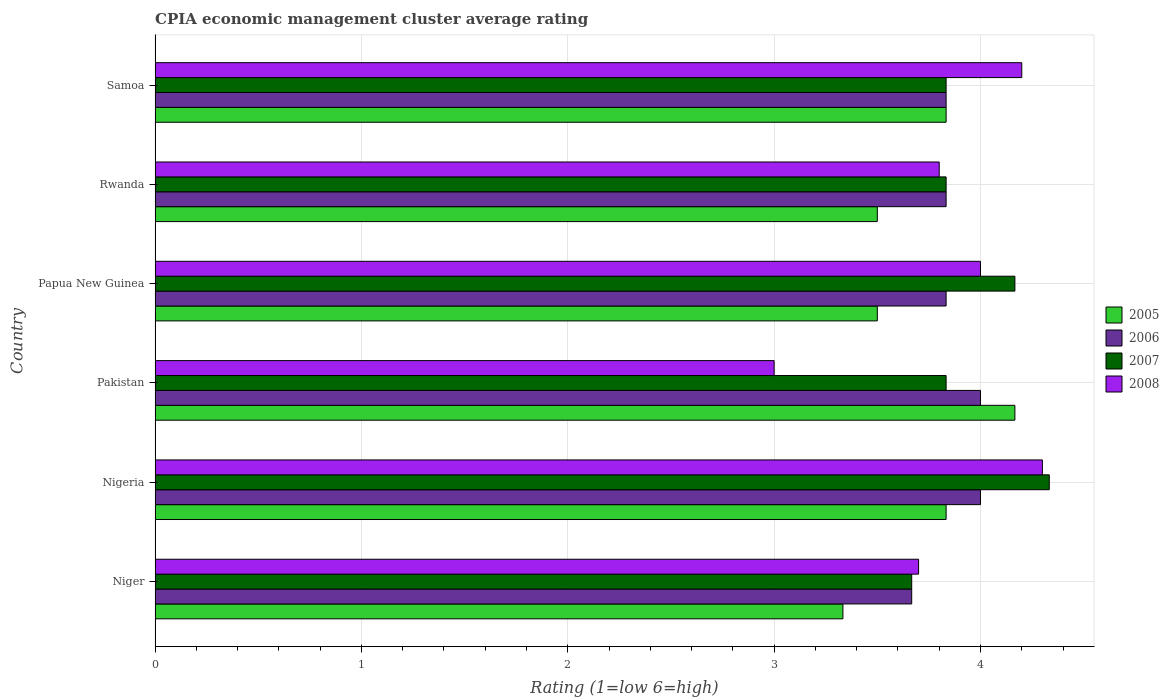How many groups of bars are there?
Keep it short and to the point. 6. Are the number of bars per tick equal to the number of legend labels?
Provide a short and direct response. Yes. How many bars are there on the 6th tick from the top?
Give a very brief answer. 4. What is the label of the 3rd group of bars from the top?
Your response must be concise. Papua New Guinea. In how many cases, is the number of bars for a given country not equal to the number of legend labels?
Your response must be concise. 0. What is the CPIA rating in 2006 in Nigeria?
Ensure brevity in your answer.  4. Across all countries, what is the maximum CPIA rating in 2007?
Offer a very short reply. 4.33. Across all countries, what is the minimum CPIA rating in 2006?
Ensure brevity in your answer.  3.67. In which country was the CPIA rating in 2007 maximum?
Your answer should be very brief. Nigeria. In which country was the CPIA rating in 2006 minimum?
Ensure brevity in your answer.  Niger. What is the total CPIA rating in 2005 in the graph?
Provide a succinct answer. 22.17. What is the difference between the CPIA rating in 2008 in Nigeria and that in Papua New Guinea?
Give a very brief answer. 0.3. What is the difference between the CPIA rating in 2008 in Papua New Guinea and the CPIA rating in 2006 in Rwanda?
Make the answer very short. 0.17. What is the average CPIA rating in 2008 per country?
Make the answer very short. 3.83. What is the difference between the CPIA rating in 2007 and CPIA rating in 2008 in Pakistan?
Offer a very short reply. 0.83. In how many countries, is the CPIA rating in 2006 greater than 2.6 ?
Provide a short and direct response. 6. What is the ratio of the CPIA rating in 2005 in Papua New Guinea to that in Samoa?
Make the answer very short. 0.91. What is the difference between the highest and the second highest CPIA rating in 2007?
Provide a short and direct response. 0.17. What is the difference between the highest and the lowest CPIA rating in 2007?
Your response must be concise. 0.67. Is the sum of the CPIA rating in 2008 in Niger and Rwanda greater than the maximum CPIA rating in 2007 across all countries?
Ensure brevity in your answer.  Yes. Is it the case that in every country, the sum of the CPIA rating in 2007 and CPIA rating in 2005 is greater than the sum of CPIA rating in 2006 and CPIA rating in 2008?
Keep it short and to the point. Yes. What does the 4th bar from the top in Samoa represents?
Provide a short and direct response. 2005. What does the 1st bar from the bottom in Nigeria represents?
Your answer should be compact. 2005. Is it the case that in every country, the sum of the CPIA rating in 2005 and CPIA rating in 2007 is greater than the CPIA rating in 2008?
Your answer should be very brief. Yes. What is the difference between two consecutive major ticks on the X-axis?
Make the answer very short. 1. Are the values on the major ticks of X-axis written in scientific E-notation?
Make the answer very short. No. Does the graph contain grids?
Provide a succinct answer. Yes. Where does the legend appear in the graph?
Ensure brevity in your answer.  Center right. How many legend labels are there?
Your response must be concise. 4. How are the legend labels stacked?
Provide a succinct answer. Vertical. What is the title of the graph?
Your answer should be very brief. CPIA economic management cluster average rating. What is the label or title of the X-axis?
Keep it short and to the point. Rating (1=low 6=high). What is the Rating (1=low 6=high) of 2005 in Niger?
Give a very brief answer. 3.33. What is the Rating (1=low 6=high) of 2006 in Niger?
Ensure brevity in your answer.  3.67. What is the Rating (1=low 6=high) in 2007 in Niger?
Keep it short and to the point. 3.67. What is the Rating (1=low 6=high) of 2008 in Niger?
Ensure brevity in your answer.  3.7. What is the Rating (1=low 6=high) of 2005 in Nigeria?
Provide a succinct answer. 3.83. What is the Rating (1=low 6=high) of 2006 in Nigeria?
Offer a very short reply. 4. What is the Rating (1=low 6=high) of 2007 in Nigeria?
Your answer should be compact. 4.33. What is the Rating (1=low 6=high) in 2005 in Pakistan?
Make the answer very short. 4.17. What is the Rating (1=low 6=high) of 2007 in Pakistan?
Give a very brief answer. 3.83. What is the Rating (1=low 6=high) of 2005 in Papua New Guinea?
Make the answer very short. 3.5. What is the Rating (1=low 6=high) in 2006 in Papua New Guinea?
Offer a terse response. 3.83. What is the Rating (1=low 6=high) in 2007 in Papua New Guinea?
Give a very brief answer. 4.17. What is the Rating (1=low 6=high) of 2008 in Papua New Guinea?
Provide a succinct answer. 4. What is the Rating (1=low 6=high) in 2006 in Rwanda?
Provide a succinct answer. 3.83. What is the Rating (1=low 6=high) in 2007 in Rwanda?
Give a very brief answer. 3.83. What is the Rating (1=low 6=high) in 2005 in Samoa?
Offer a terse response. 3.83. What is the Rating (1=low 6=high) in 2006 in Samoa?
Offer a terse response. 3.83. What is the Rating (1=low 6=high) of 2007 in Samoa?
Offer a very short reply. 3.83. What is the Rating (1=low 6=high) in 2008 in Samoa?
Keep it short and to the point. 4.2. Across all countries, what is the maximum Rating (1=low 6=high) of 2005?
Your response must be concise. 4.17. Across all countries, what is the maximum Rating (1=low 6=high) of 2007?
Offer a terse response. 4.33. Across all countries, what is the maximum Rating (1=low 6=high) of 2008?
Keep it short and to the point. 4.3. Across all countries, what is the minimum Rating (1=low 6=high) in 2005?
Your answer should be compact. 3.33. Across all countries, what is the minimum Rating (1=low 6=high) of 2006?
Your response must be concise. 3.67. Across all countries, what is the minimum Rating (1=low 6=high) of 2007?
Your response must be concise. 3.67. Across all countries, what is the minimum Rating (1=low 6=high) in 2008?
Offer a very short reply. 3. What is the total Rating (1=low 6=high) in 2005 in the graph?
Give a very brief answer. 22.17. What is the total Rating (1=low 6=high) of 2006 in the graph?
Offer a very short reply. 23.17. What is the total Rating (1=low 6=high) in 2007 in the graph?
Your answer should be very brief. 23.67. What is the total Rating (1=low 6=high) in 2008 in the graph?
Make the answer very short. 23. What is the difference between the Rating (1=low 6=high) in 2006 in Niger and that in Nigeria?
Your answer should be very brief. -0.33. What is the difference between the Rating (1=low 6=high) of 2007 in Niger and that in Nigeria?
Offer a very short reply. -0.67. What is the difference between the Rating (1=low 6=high) of 2008 in Niger and that in Nigeria?
Give a very brief answer. -0.6. What is the difference between the Rating (1=low 6=high) of 2006 in Niger and that in Pakistan?
Keep it short and to the point. -0.33. What is the difference between the Rating (1=low 6=high) of 2008 in Niger and that in Pakistan?
Your answer should be compact. 0.7. What is the difference between the Rating (1=low 6=high) in 2005 in Niger and that in Papua New Guinea?
Offer a terse response. -0.17. What is the difference between the Rating (1=low 6=high) in 2007 in Niger and that in Papua New Guinea?
Offer a very short reply. -0.5. What is the difference between the Rating (1=low 6=high) of 2005 in Niger and that in Rwanda?
Offer a terse response. -0.17. What is the difference between the Rating (1=low 6=high) of 2008 in Niger and that in Rwanda?
Ensure brevity in your answer.  -0.1. What is the difference between the Rating (1=low 6=high) of 2005 in Niger and that in Samoa?
Provide a short and direct response. -0.5. What is the difference between the Rating (1=low 6=high) of 2007 in Niger and that in Samoa?
Offer a very short reply. -0.17. What is the difference between the Rating (1=low 6=high) in 2007 in Nigeria and that in Pakistan?
Offer a very short reply. 0.5. What is the difference between the Rating (1=low 6=high) of 2008 in Nigeria and that in Pakistan?
Keep it short and to the point. 1.3. What is the difference between the Rating (1=low 6=high) of 2005 in Nigeria and that in Papua New Guinea?
Your answer should be very brief. 0.33. What is the difference between the Rating (1=low 6=high) in 2008 in Nigeria and that in Papua New Guinea?
Ensure brevity in your answer.  0.3. What is the difference between the Rating (1=low 6=high) of 2005 in Nigeria and that in Rwanda?
Your response must be concise. 0.33. What is the difference between the Rating (1=low 6=high) of 2006 in Nigeria and that in Rwanda?
Provide a short and direct response. 0.17. What is the difference between the Rating (1=low 6=high) in 2008 in Nigeria and that in Rwanda?
Ensure brevity in your answer.  0.5. What is the difference between the Rating (1=low 6=high) of 2005 in Nigeria and that in Samoa?
Offer a very short reply. 0. What is the difference between the Rating (1=low 6=high) in 2006 in Nigeria and that in Samoa?
Offer a terse response. 0.17. What is the difference between the Rating (1=low 6=high) of 2007 in Nigeria and that in Samoa?
Your answer should be very brief. 0.5. What is the difference between the Rating (1=low 6=high) of 2007 in Pakistan and that in Papua New Guinea?
Your answer should be compact. -0.33. What is the difference between the Rating (1=low 6=high) of 2008 in Pakistan and that in Papua New Guinea?
Provide a succinct answer. -1. What is the difference between the Rating (1=low 6=high) in 2008 in Pakistan and that in Rwanda?
Ensure brevity in your answer.  -0.8. What is the difference between the Rating (1=low 6=high) of 2005 in Pakistan and that in Samoa?
Give a very brief answer. 0.33. What is the difference between the Rating (1=low 6=high) in 2006 in Pakistan and that in Samoa?
Offer a terse response. 0.17. What is the difference between the Rating (1=low 6=high) in 2007 in Pakistan and that in Samoa?
Ensure brevity in your answer.  0. What is the difference between the Rating (1=low 6=high) in 2008 in Pakistan and that in Samoa?
Give a very brief answer. -1.2. What is the difference between the Rating (1=low 6=high) of 2005 in Papua New Guinea and that in Rwanda?
Give a very brief answer. 0. What is the difference between the Rating (1=low 6=high) in 2006 in Papua New Guinea and that in Rwanda?
Ensure brevity in your answer.  0. What is the difference between the Rating (1=low 6=high) in 2007 in Papua New Guinea and that in Rwanda?
Make the answer very short. 0.33. What is the difference between the Rating (1=low 6=high) in 2008 in Papua New Guinea and that in Rwanda?
Offer a very short reply. 0.2. What is the difference between the Rating (1=low 6=high) in 2005 in Papua New Guinea and that in Samoa?
Offer a very short reply. -0.33. What is the difference between the Rating (1=low 6=high) in 2006 in Papua New Guinea and that in Samoa?
Your response must be concise. 0. What is the difference between the Rating (1=low 6=high) of 2007 in Papua New Guinea and that in Samoa?
Offer a terse response. 0.33. What is the difference between the Rating (1=low 6=high) of 2006 in Rwanda and that in Samoa?
Give a very brief answer. 0. What is the difference between the Rating (1=low 6=high) in 2005 in Niger and the Rating (1=low 6=high) in 2006 in Nigeria?
Keep it short and to the point. -0.67. What is the difference between the Rating (1=low 6=high) in 2005 in Niger and the Rating (1=low 6=high) in 2007 in Nigeria?
Offer a very short reply. -1. What is the difference between the Rating (1=low 6=high) in 2005 in Niger and the Rating (1=low 6=high) in 2008 in Nigeria?
Your answer should be very brief. -0.97. What is the difference between the Rating (1=low 6=high) of 2006 in Niger and the Rating (1=low 6=high) of 2008 in Nigeria?
Offer a terse response. -0.63. What is the difference between the Rating (1=low 6=high) in 2007 in Niger and the Rating (1=low 6=high) in 2008 in Nigeria?
Give a very brief answer. -0.63. What is the difference between the Rating (1=low 6=high) of 2005 in Niger and the Rating (1=low 6=high) of 2006 in Pakistan?
Offer a terse response. -0.67. What is the difference between the Rating (1=low 6=high) of 2005 in Niger and the Rating (1=low 6=high) of 2007 in Pakistan?
Offer a terse response. -0.5. What is the difference between the Rating (1=low 6=high) of 2006 in Niger and the Rating (1=low 6=high) of 2007 in Pakistan?
Make the answer very short. -0.17. What is the difference between the Rating (1=low 6=high) in 2005 in Niger and the Rating (1=low 6=high) in 2006 in Papua New Guinea?
Provide a short and direct response. -0.5. What is the difference between the Rating (1=low 6=high) in 2005 in Niger and the Rating (1=low 6=high) in 2008 in Papua New Guinea?
Your answer should be compact. -0.67. What is the difference between the Rating (1=low 6=high) of 2007 in Niger and the Rating (1=low 6=high) of 2008 in Papua New Guinea?
Provide a succinct answer. -0.33. What is the difference between the Rating (1=low 6=high) of 2005 in Niger and the Rating (1=low 6=high) of 2006 in Rwanda?
Your answer should be compact. -0.5. What is the difference between the Rating (1=low 6=high) in 2005 in Niger and the Rating (1=low 6=high) in 2008 in Rwanda?
Your answer should be very brief. -0.47. What is the difference between the Rating (1=low 6=high) in 2006 in Niger and the Rating (1=low 6=high) in 2008 in Rwanda?
Ensure brevity in your answer.  -0.13. What is the difference between the Rating (1=low 6=high) in 2007 in Niger and the Rating (1=low 6=high) in 2008 in Rwanda?
Your answer should be compact. -0.13. What is the difference between the Rating (1=low 6=high) in 2005 in Niger and the Rating (1=low 6=high) in 2007 in Samoa?
Provide a short and direct response. -0.5. What is the difference between the Rating (1=low 6=high) in 2005 in Niger and the Rating (1=low 6=high) in 2008 in Samoa?
Provide a succinct answer. -0.87. What is the difference between the Rating (1=low 6=high) in 2006 in Niger and the Rating (1=low 6=high) in 2008 in Samoa?
Offer a terse response. -0.53. What is the difference between the Rating (1=low 6=high) in 2007 in Niger and the Rating (1=low 6=high) in 2008 in Samoa?
Provide a short and direct response. -0.53. What is the difference between the Rating (1=low 6=high) in 2005 in Nigeria and the Rating (1=low 6=high) in 2006 in Pakistan?
Your response must be concise. -0.17. What is the difference between the Rating (1=low 6=high) of 2005 in Nigeria and the Rating (1=low 6=high) of 2007 in Pakistan?
Provide a short and direct response. 0. What is the difference between the Rating (1=low 6=high) in 2006 in Nigeria and the Rating (1=low 6=high) in 2007 in Pakistan?
Provide a short and direct response. 0.17. What is the difference between the Rating (1=low 6=high) in 2007 in Nigeria and the Rating (1=low 6=high) in 2008 in Pakistan?
Offer a very short reply. 1.33. What is the difference between the Rating (1=low 6=high) of 2005 in Nigeria and the Rating (1=low 6=high) of 2006 in Papua New Guinea?
Ensure brevity in your answer.  0. What is the difference between the Rating (1=low 6=high) of 2005 in Nigeria and the Rating (1=low 6=high) of 2007 in Papua New Guinea?
Give a very brief answer. -0.33. What is the difference between the Rating (1=low 6=high) of 2005 in Nigeria and the Rating (1=low 6=high) of 2008 in Papua New Guinea?
Keep it short and to the point. -0.17. What is the difference between the Rating (1=low 6=high) of 2007 in Nigeria and the Rating (1=low 6=high) of 2008 in Papua New Guinea?
Your response must be concise. 0.33. What is the difference between the Rating (1=low 6=high) of 2005 in Nigeria and the Rating (1=low 6=high) of 2008 in Rwanda?
Your response must be concise. 0.03. What is the difference between the Rating (1=low 6=high) of 2006 in Nigeria and the Rating (1=low 6=high) of 2007 in Rwanda?
Offer a terse response. 0.17. What is the difference between the Rating (1=low 6=high) in 2006 in Nigeria and the Rating (1=low 6=high) in 2008 in Rwanda?
Give a very brief answer. 0.2. What is the difference between the Rating (1=low 6=high) of 2007 in Nigeria and the Rating (1=low 6=high) of 2008 in Rwanda?
Keep it short and to the point. 0.53. What is the difference between the Rating (1=low 6=high) of 2005 in Nigeria and the Rating (1=low 6=high) of 2008 in Samoa?
Your answer should be compact. -0.37. What is the difference between the Rating (1=low 6=high) in 2007 in Nigeria and the Rating (1=low 6=high) in 2008 in Samoa?
Offer a very short reply. 0.13. What is the difference between the Rating (1=low 6=high) of 2005 in Pakistan and the Rating (1=low 6=high) of 2006 in Papua New Guinea?
Your answer should be compact. 0.33. What is the difference between the Rating (1=low 6=high) of 2007 in Pakistan and the Rating (1=low 6=high) of 2008 in Papua New Guinea?
Ensure brevity in your answer.  -0.17. What is the difference between the Rating (1=low 6=high) of 2005 in Pakistan and the Rating (1=low 6=high) of 2008 in Rwanda?
Keep it short and to the point. 0.37. What is the difference between the Rating (1=low 6=high) in 2006 in Pakistan and the Rating (1=low 6=high) in 2008 in Rwanda?
Offer a very short reply. 0.2. What is the difference between the Rating (1=low 6=high) of 2005 in Pakistan and the Rating (1=low 6=high) of 2006 in Samoa?
Make the answer very short. 0.33. What is the difference between the Rating (1=low 6=high) in 2005 in Pakistan and the Rating (1=low 6=high) in 2008 in Samoa?
Offer a terse response. -0.03. What is the difference between the Rating (1=low 6=high) in 2006 in Pakistan and the Rating (1=low 6=high) in 2007 in Samoa?
Ensure brevity in your answer.  0.17. What is the difference between the Rating (1=low 6=high) of 2007 in Pakistan and the Rating (1=low 6=high) of 2008 in Samoa?
Your answer should be compact. -0.37. What is the difference between the Rating (1=low 6=high) of 2006 in Papua New Guinea and the Rating (1=low 6=high) of 2008 in Rwanda?
Keep it short and to the point. 0.03. What is the difference between the Rating (1=low 6=high) in 2007 in Papua New Guinea and the Rating (1=low 6=high) in 2008 in Rwanda?
Your answer should be very brief. 0.37. What is the difference between the Rating (1=low 6=high) in 2006 in Papua New Guinea and the Rating (1=low 6=high) in 2007 in Samoa?
Provide a succinct answer. 0. What is the difference between the Rating (1=low 6=high) in 2006 in Papua New Guinea and the Rating (1=low 6=high) in 2008 in Samoa?
Keep it short and to the point. -0.37. What is the difference between the Rating (1=low 6=high) in 2007 in Papua New Guinea and the Rating (1=low 6=high) in 2008 in Samoa?
Provide a short and direct response. -0.03. What is the difference between the Rating (1=low 6=high) of 2005 in Rwanda and the Rating (1=low 6=high) of 2006 in Samoa?
Provide a short and direct response. -0.33. What is the difference between the Rating (1=low 6=high) in 2006 in Rwanda and the Rating (1=low 6=high) in 2008 in Samoa?
Offer a very short reply. -0.37. What is the difference between the Rating (1=low 6=high) in 2007 in Rwanda and the Rating (1=low 6=high) in 2008 in Samoa?
Your answer should be compact. -0.37. What is the average Rating (1=low 6=high) of 2005 per country?
Your answer should be very brief. 3.69. What is the average Rating (1=low 6=high) of 2006 per country?
Provide a succinct answer. 3.86. What is the average Rating (1=low 6=high) of 2007 per country?
Provide a short and direct response. 3.94. What is the average Rating (1=low 6=high) of 2008 per country?
Offer a terse response. 3.83. What is the difference between the Rating (1=low 6=high) of 2005 and Rating (1=low 6=high) of 2006 in Niger?
Provide a succinct answer. -0.33. What is the difference between the Rating (1=low 6=high) in 2005 and Rating (1=low 6=high) in 2007 in Niger?
Your answer should be very brief. -0.33. What is the difference between the Rating (1=low 6=high) of 2005 and Rating (1=low 6=high) of 2008 in Niger?
Offer a terse response. -0.37. What is the difference between the Rating (1=low 6=high) in 2006 and Rating (1=low 6=high) in 2007 in Niger?
Make the answer very short. 0. What is the difference between the Rating (1=low 6=high) in 2006 and Rating (1=low 6=high) in 2008 in Niger?
Your response must be concise. -0.03. What is the difference between the Rating (1=low 6=high) in 2007 and Rating (1=low 6=high) in 2008 in Niger?
Offer a very short reply. -0.03. What is the difference between the Rating (1=low 6=high) of 2005 and Rating (1=low 6=high) of 2006 in Nigeria?
Provide a succinct answer. -0.17. What is the difference between the Rating (1=low 6=high) in 2005 and Rating (1=low 6=high) in 2007 in Nigeria?
Give a very brief answer. -0.5. What is the difference between the Rating (1=low 6=high) of 2005 and Rating (1=low 6=high) of 2008 in Nigeria?
Provide a short and direct response. -0.47. What is the difference between the Rating (1=low 6=high) of 2006 and Rating (1=low 6=high) of 2008 in Nigeria?
Your answer should be very brief. -0.3. What is the difference between the Rating (1=low 6=high) in 2005 and Rating (1=low 6=high) in 2007 in Pakistan?
Ensure brevity in your answer.  0.33. What is the difference between the Rating (1=low 6=high) of 2005 and Rating (1=low 6=high) of 2008 in Pakistan?
Provide a succinct answer. 1.17. What is the difference between the Rating (1=low 6=high) of 2005 and Rating (1=low 6=high) of 2007 in Papua New Guinea?
Ensure brevity in your answer.  -0.67. What is the difference between the Rating (1=low 6=high) in 2006 and Rating (1=low 6=high) in 2007 in Papua New Guinea?
Ensure brevity in your answer.  -0.33. What is the difference between the Rating (1=low 6=high) of 2006 and Rating (1=low 6=high) of 2008 in Papua New Guinea?
Provide a succinct answer. -0.17. What is the difference between the Rating (1=low 6=high) of 2007 and Rating (1=low 6=high) of 2008 in Papua New Guinea?
Provide a short and direct response. 0.17. What is the difference between the Rating (1=low 6=high) in 2005 and Rating (1=low 6=high) in 2007 in Rwanda?
Offer a terse response. -0.33. What is the difference between the Rating (1=low 6=high) in 2005 and Rating (1=low 6=high) in 2008 in Rwanda?
Your answer should be very brief. -0.3. What is the difference between the Rating (1=low 6=high) of 2006 and Rating (1=low 6=high) of 2007 in Rwanda?
Your response must be concise. 0. What is the difference between the Rating (1=low 6=high) in 2007 and Rating (1=low 6=high) in 2008 in Rwanda?
Offer a terse response. 0.03. What is the difference between the Rating (1=low 6=high) in 2005 and Rating (1=low 6=high) in 2007 in Samoa?
Keep it short and to the point. 0. What is the difference between the Rating (1=low 6=high) in 2005 and Rating (1=low 6=high) in 2008 in Samoa?
Offer a terse response. -0.37. What is the difference between the Rating (1=low 6=high) in 2006 and Rating (1=low 6=high) in 2008 in Samoa?
Your answer should be compact. -0.37. What is the difference between the Rating (1=low 6=high) of 2007 and Rating (1=low 6=high) of 2008 in Samoa?
Your answer should be very brief. -0.37. What is the ratio of the Rating (1=low 6=high) of 2005 in Niger to that in Nigeria?
Make the answer very short. 0.87. What is the ratio of the Rating (1=low 6=high) of 2007 in Niger to that in Nigeria?
Keep it short and to the point. 0.85. What is the ratio of the Rating (1=low 6=high) of 2008 in Niger to that in Nigeria?
Keep it short and to the point. 0.86. What is the ratio of the Rating (1=low 6=high) of 2005 in Niger to that in Pakistan?
Offer a terse response. 0.8. What is the ratio of the Rating (1=low 6=high) of 2007 in Niger to that in Pakistan?
Your response must be concise. 0.96. What is the ratio of the Rating (1=low 6=high) of 2008 in Niger to that in Pakistan?
Make the answer very short. 1.23. What is the ratio of the Rating (1=low 6=high) of 2005 in Niger to that in Papua New Guinea?
Make the answer very short. 0.95. What is the ratio of the Rating (1=low 6=high) in 2006 in Niger to that in Papua New Guinea?
Keep it short and to the point. 0.96. What is the ratio of the Rating (1=low 6=high) of 2008 in Niger to that in Papua New Guinea?
Your answer should be very brief. 0.93. What is the ratio of the Rating (1=low 6=high) in 2006 in Niger to that in Rwanda?
Keep it short and to the point. 0.96. What is the ratio of the Rating (1=low 6=high) in 2007 in Niger to that in Rwanda?
Provide a short and direct response. 0.96. What is the ratio of the Rating (1=low 6=high) of 2008 in Niger to that in Rwanda?
Give a very brief answer. 0.97. What is the ratio of the Rating (1=low 6=high) of 2005 in Niger to that in Samoa?
Your answer should be very brief. 0.87. What is the ratio of the Rating (1=low 6=high) in 2006 in Niger to that in Samoa?
Ensure brevity in your answer.  0.96. What is the ratio of the Rating (1=low 6=high) in 2007 in Niger to that in Samoa?
Your answer should be very brief. 0.96. What is the ratio of the Rating (1=low 6=high) of 2008 in Niger to that in Samoa?
Provide a short and direct response. 0.88. What is the ratio of the Rating (1=low 6=high) of 2006 in Nigeria to that in Pakistan?
Your answer should be compact. 1. What is the ratio of the Rating (1=low 6=high) of 2007 in Nigeria to that in Pakistan?
Keep it short and to the point. 1.13. What is the ratio of the Rating (1=low 6=high) of 2008 in Nigeria to that in Pakistan?
Your answer should be very brief. 1.43. What is the ratio of the Rating (1=low 6=high) in 2005 in Nigeria to that in Papua New Guinea?
Give a very brief answer. 1.1. What is the ratio of the Rating (1=low 6=high) of 2006 in Nigeria to that in Papua New Guinea?
Your answer should be very brief. 1.04. What is the ratio of the Rating (1=low 6=high) in 2008 in Nigeria to that in Papua New Guinea?
Keep it short and to the point. 1.07. What is the ratio of the Rating (1=low 6=high) of 2005 in Nigeria to that in Rwanda?
Ensure brevity in your answer.  1.1. What is the ratio of the Rating (1=low 6=high) in 2006 in Nigeria to that in Rwanda?
Ensure brevity in your answer.  1.04. What is the ratio of the Rating (1=low 6=high) of 2007 in Nigeria to that in Rwanda?
Provide a succinct answer. 1.13. What is the ratio of the Rating (1=low 6=high) of 2008 in Nigeria to that in Rwanda?
Provide a succinct answer. 1.13. What is the ratio of the Rating (1=low 6=high) of 2005 in Nigeria to that in Samoa?
Provide a short and direct response. 1. What is the ratio of the Rating (1=low 6=high) of 2006 in Nigeria to that in Samoa?
Give a very brief answer. 1.04. What is the ratio of the Rating (1=low 6=high) in 2007 in Nigeria to that in Samoa?
Give a very brief answer. 1.13. What is the ratio of the Rating (1=low 6=high) in 2008 in Nigeria to that in Samoa?
Your response must be concise. 1.02. What is the ratio of the Rating (1=low 6=high) of 2005 in Pakistan to that in Papua New Guinea?
Keep it short and to the point. 1.19. What is the ratio of the Rating (1=low 6=high) in 2006 in Pakistan to that in Papua New Guinea?
Your response must be concise. 1.04. What is the ratio of the Rating (1=low 6=high) in 2007 in Pakistan to that in Papua New Guinea?
Your answer should be very brief. 0.92. What is the ratio of the Rating (1=low 6=high) in 2008 in Pakistan to that in Papua New Guinea?
Offer a terse response. 0.75. What is the ratio of the Rating (1=low 6=high) of 2005 in Pakistan to that in Rwanda?
Give a very brief answer. 1.19. What is the ratio of the Rating (1=low 6=high) of 2006 in Pakistan to that in Rwanda?
Keep it short and to the point. 1.04. What is the ratio of the Rating (1=low 6=high) in 2008 in Pakistan to that in Rwanda?
Offer a terse response. 0.79. What is the ratio of the Rating (1=low 6=high) in 2005 in Pakistan to that in Samoa?
Offer a terse response. 1.09. What is the ratio of the Rating (1=low 6=high) of 2006 in Pakistan to that in Samoa?
Ensure brevity in your answer.  1.04. What is the ratio of the Rating (1=low 6=high) in 2005 in Papua New Guinea to that in Rwanda?
Offer a terse response. 1. What is the ratio of the Rating (1=low 6=high) in 2006 in Papua New Guinea to that in Rwanda?
Ensure brevity in your answer.  1. What is the ratio of the Rating (1=low 6=high) of 2007 in Papua New Guinea to that in Rwanda?
Offer a very short reply. 1.09. What is the ratio of the Rating (1=low 6=high) in 2008 in Papua New Guinea to that in Rwanda?
Your response must be concise. 1.05. What is the ratio of the Rating (1=low 6=high) of 2005 in Papua New Guinea to that in Samoa?
Your response must be concise. 0.91. What is the ratio of the Rating (1=low 6=high) in 2007 in Papua New Guinea to that in Samoa?
Your answer should be very brief. 1.09. What is the ratio of the Rating (1=low 6=high) in 2008 in Papua New Guinea to that in Samoa?
Keep it short and to the point. 0.95. What is the ratio of the Rating (1=low 6=high) in 2006 in Rwanda to that in Samoa?
Give a very brief answer. 1. What is the ratio of the Rating (1=low 6=high) of 2007 in Rwanda to that in Samoa?
Make the answer very short. 1. What is the ratio of the Rating (1=low 6=high) of 2008 in Rwanda to that in Samoa?
Your answer should be very brief. 0.9. What is the difference between the highest and the second highest Rating (1=low 6=high) in 2006?
Provide a short and direct response. 0. What is the difference between the highest and the second highest Rating (1=low 6=high) of 2008?
Your answer should be compact. 0.1. What is the difference between the highest and the lowest Rating (1=low 6=high) in 2005?
Your response must be concise. 0.83. What is the difference between the highest and the lowest Rating (1=low 6=high) in 2006?
Make the answer very short. 0.33. What is the difference between the highest and the lowest Rating (1=low 6=high) in 2007?
Offer a very short reply. 0.67. What is the difference between the highest and the lowest Rating (1=low 6=high) of 2008?
Your answer should be compact. 1.3. 